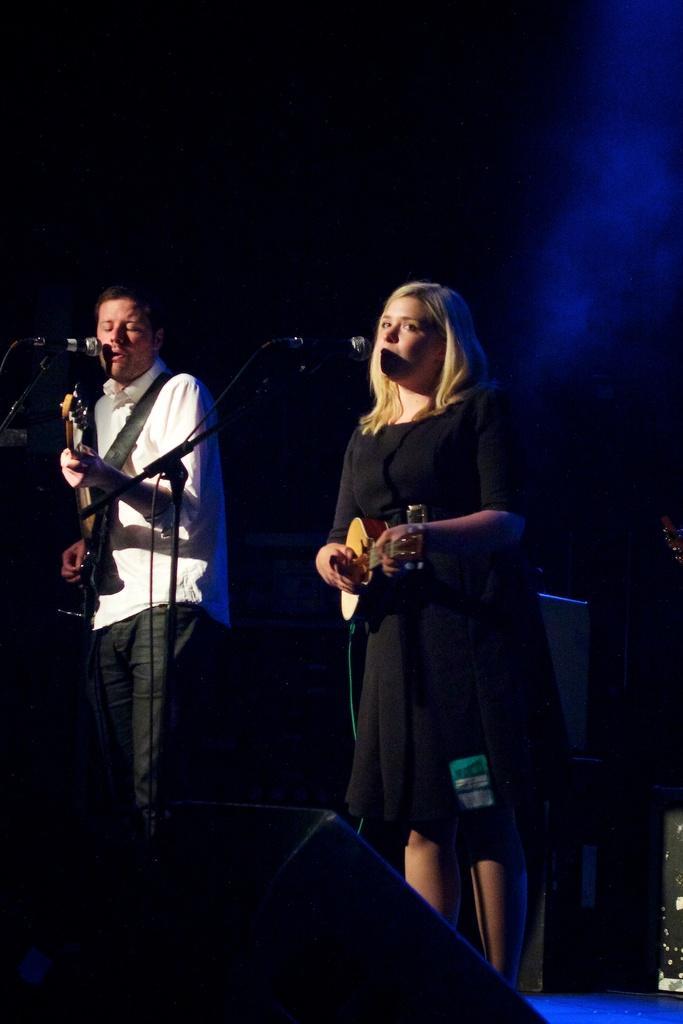Can you describe this image briefly? In this image there is a girl who is holding the guitar in her hand and playing and their is a man beside her who is playing the guitar while singing. 